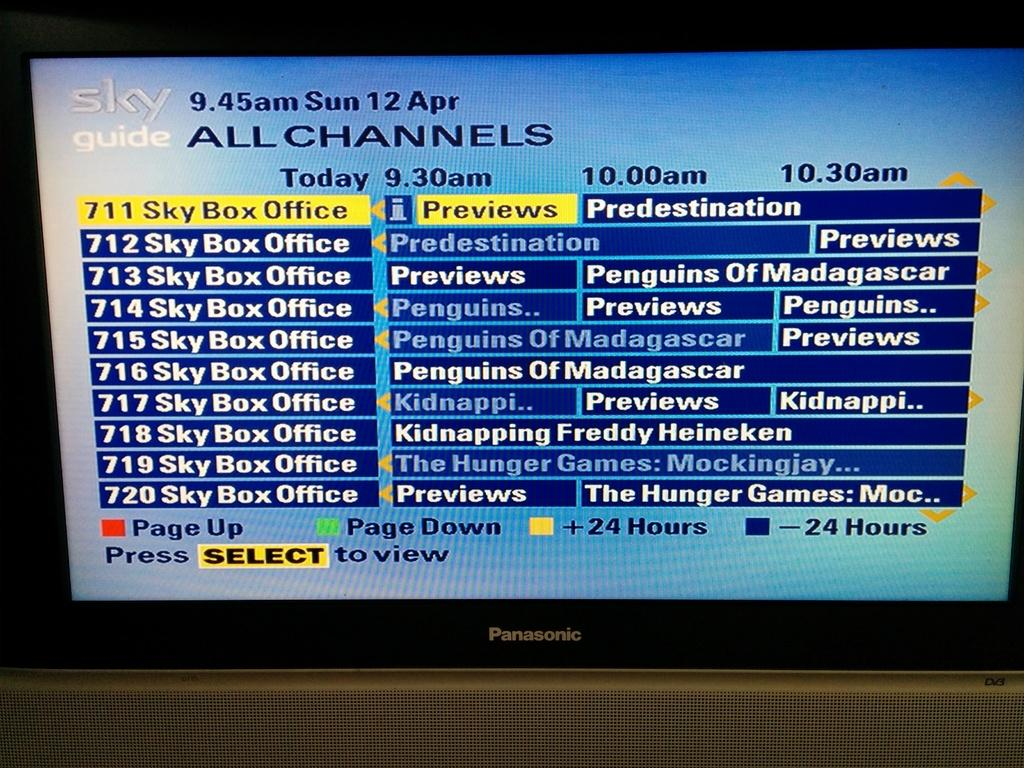<image>
Share a concise interpretation of the image provided. A Panasonic TV tuned in to the Sky Guide channel. 